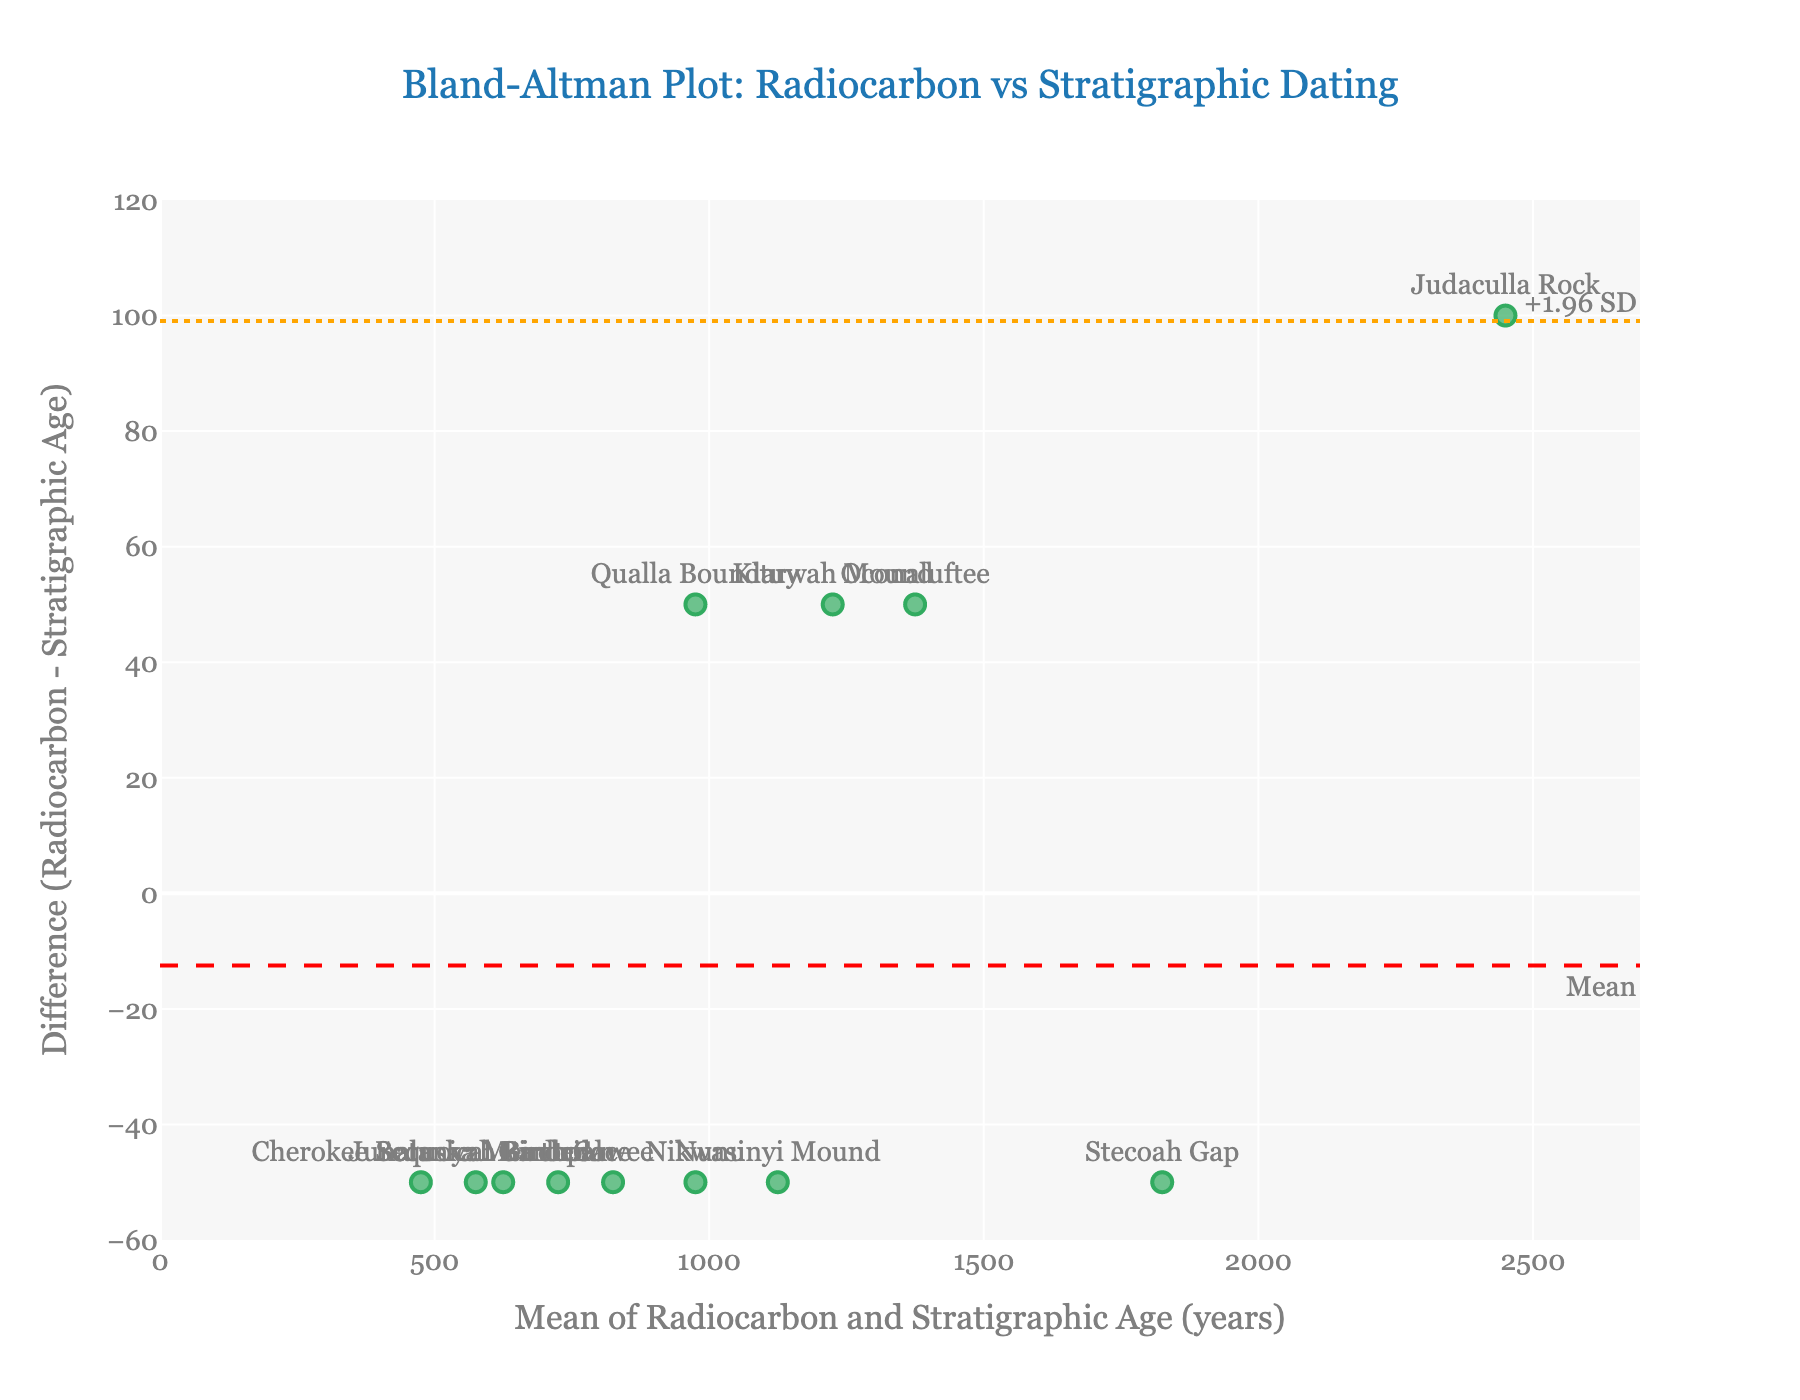What's the title of the figure? The title is usually displayed prominently at the top of the figure. In this case, it reads "Bland-Altman Plot: Radiocarbon vs Stratigraphic Dating".
Answer: Bland-Altman Plot: Radiocarbon vs Stratigraphic Dating What is the y-axis label of the plot? The y-axis label indicates what data is being displayed on that axis. Here, it is labeled "Difference (Radiocarbon - Stratigraphic Age)".
Answer: Difference (Radiocarbon - Stratigraphic Age) How many data points are shown in the plot? Each archaeological site is represented by one data point in the plot. Given that there are names of 12 sites listed in the data, there should be 12 data points.
Answer: 12 What is the range of the x-axis in this plot? The x-axis represents the mean of Radiocarbon and Stratigraphic Age. The plot's axis range is set to show from 0 to just beyond the maximum mean value. Calculating the maximum mean from the data provided: mean((2500+2400)/2 = 2450). Therefore, the x-axis should range approximately from 0 to 2450 * 1.1, which equates to around 0 to 2695.
Answer: 0 to 2695 What are the upper and lower limits of agreement in the plot? The limits of agreement are usually shown as dotted lines along with their corresponding values on the plot. In this figure, they are labeled as "+1.96 SD" and "-1.96 SD".
Answer: +1.96 SD and -1.96 SD Which site has the largest difference between Radiocarbon and Stratigraphic Ages? The data point with the largest vertical distance (positive or negative) from zero on the y-axis represents the largest difference. From the given data, Judaculla Rock has a difference of 2500 - 2400 = 100, which is the largest.
Answer: Judaculla Rock Which site shows the smallest difference between Radiocarbon and Stratigraphic Ages? The data point closest to the zero line on the y-axis represents the smallest difference. From the given data, Oconaluftee has a difference of 1400 - 1350 = 50, which is the smallest.
Answer: Oconaluftee How does the spread of differences relate to the mean differences? The spread of the data points on the y-axis (difference) relative to their values on the x-axis (mean age) indicates if there is any systematic bias or pattern. Noticing if the data points lie evenly around the mean line or show a trend helps understand this relationship.
Answer: The spread appears consistent with no apparent systematic bias What does the red dashed line in the plot represent? In a Bland-Altman plot, the red dashed line typically represents the mean difference between the two methods being compared.
Answer: Mean difference Are there any sites where the Radiocarbon Age is exactly equal to the Stratigraphic Age? To check if Radiocarbon Age equals Stratigraphic Age, we need to see if any data points lie exactly on the zero line of the y-axis indicating no difference. Here, none of the sites lie on the zero line.
Answer: No 